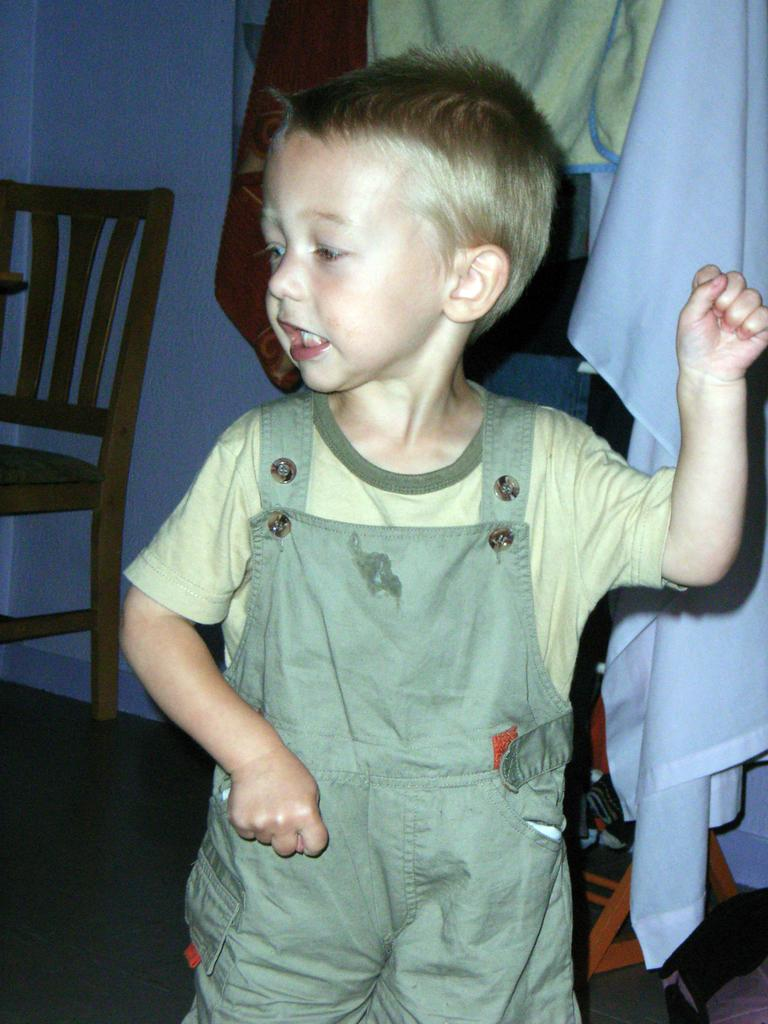What is the main subject of the image? There is a boy standing in the image. What can be seen in the background of the image? There are clothes and a chair in the background of the image. What type of insurance policy is the boy holding in the image? There is no insurance policy present in the image; it features a boy standing with clothes and a chair in the background. Can you tell me how many geese are visible in the image? There are no geese present in the image. 